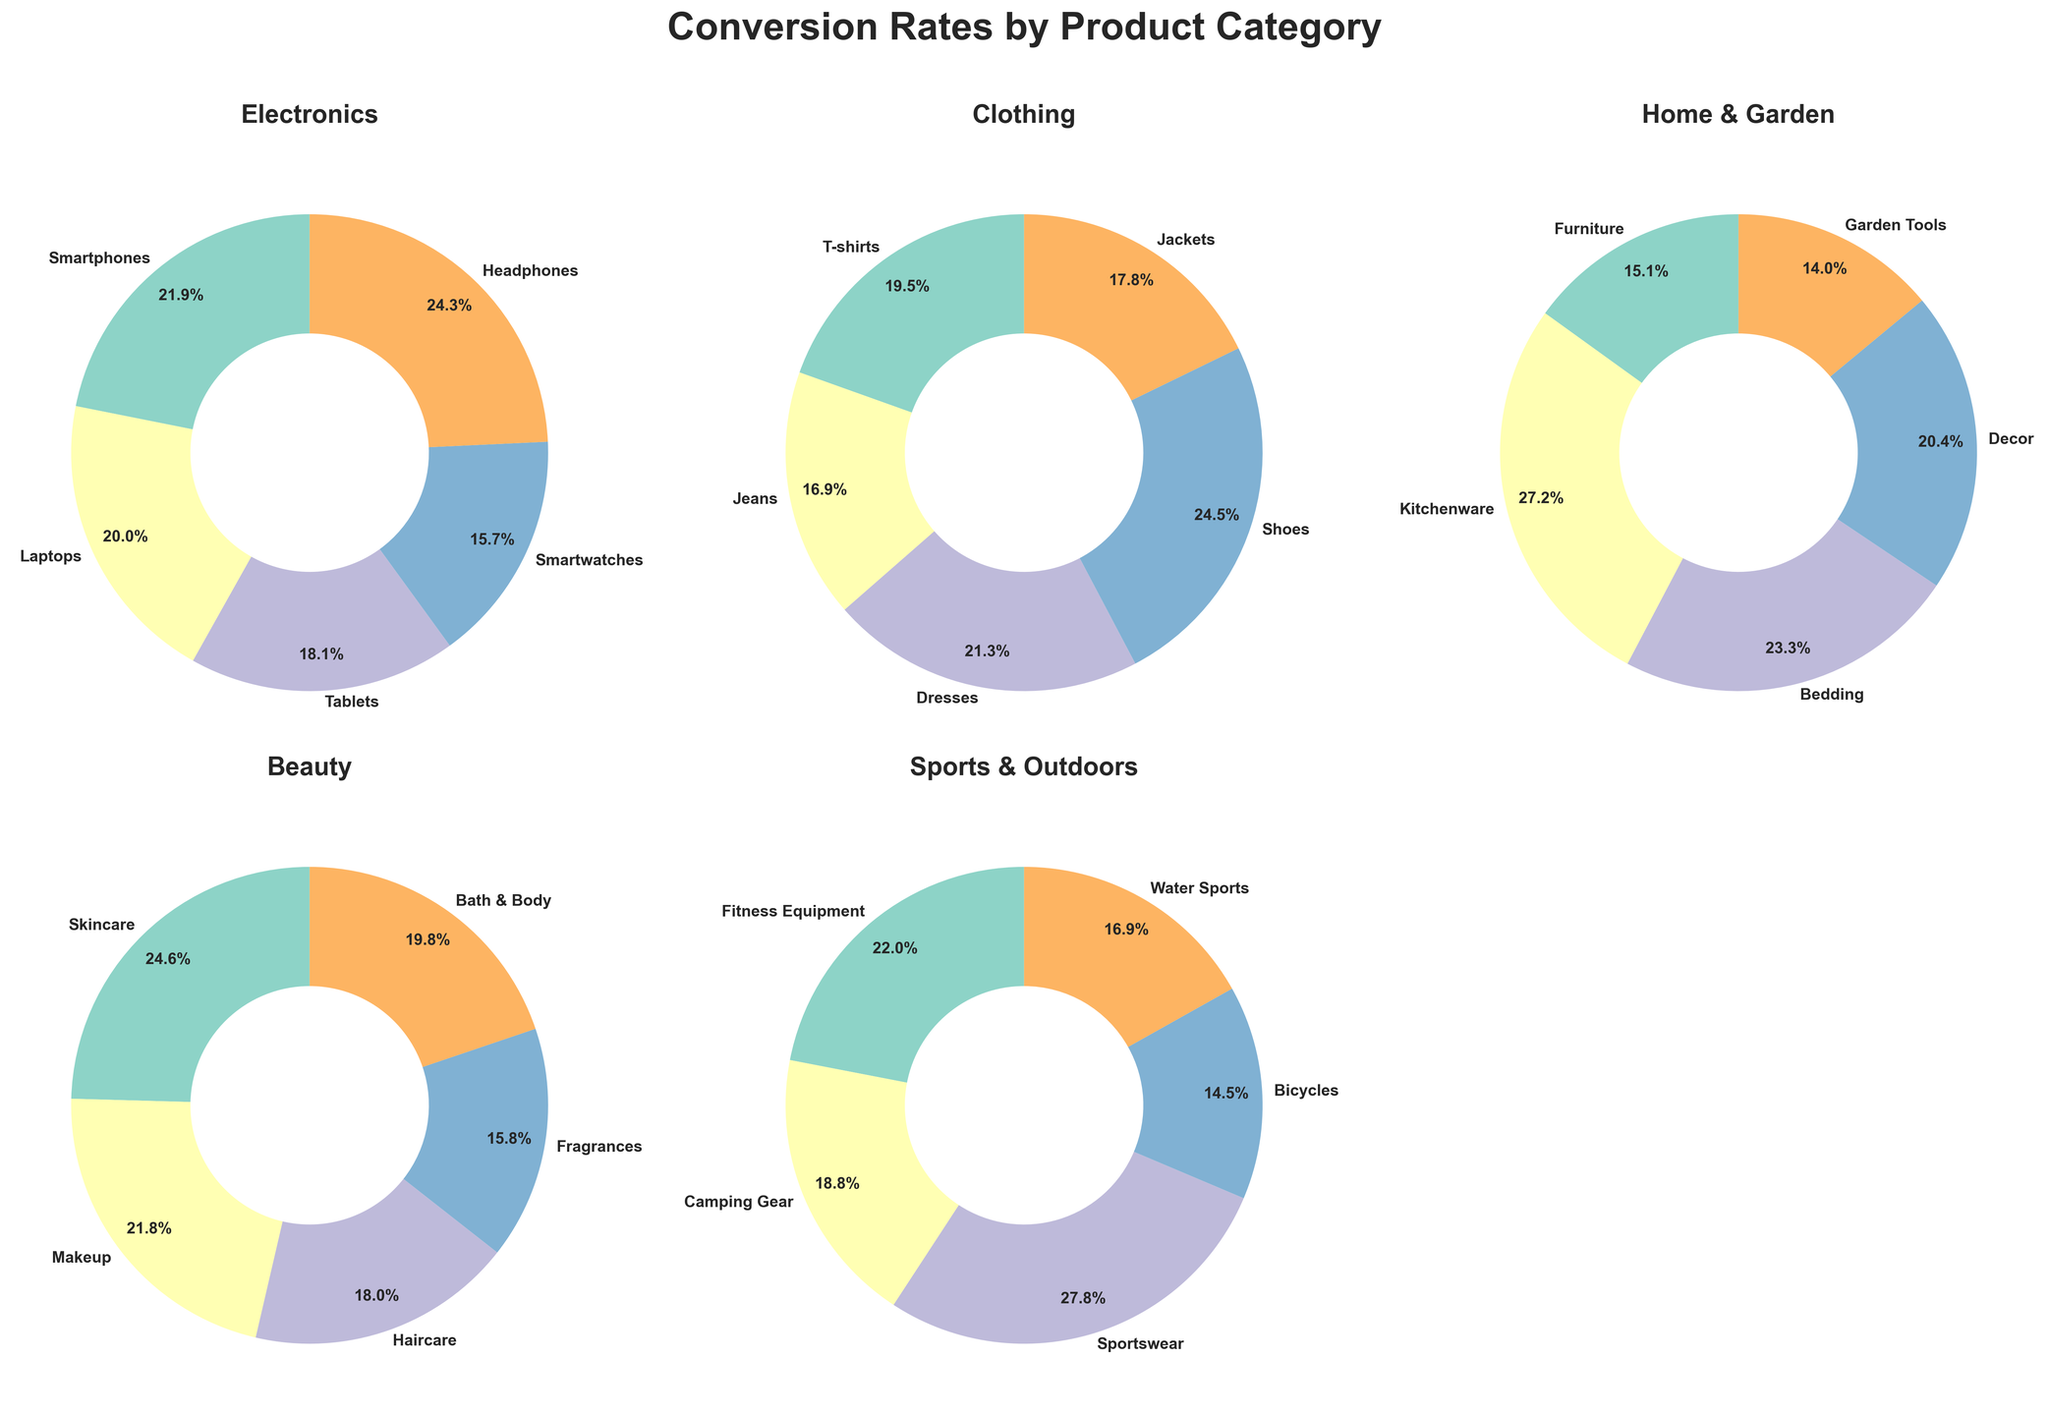Which product in the Electronics category has the highest conversion rate? In the Electronics category pie chart, Headphones have the largest section, indicating the highest conversion rate.
Answer: Headphones What is the total conversion rate for the products in the Beauty category? Sum the conversion rates for all products in the Beauty category from the pie chart: 9.8% (Skincare) + 8.7% (Makeup) + 7.2% (Haircare) + 6.3% (Fragrances) + 7.9% (Bath & Body) = 39.9%.
Answer: 39.9% Compare the conversion rate for T-shirts and Shoes in the Clothing category. Which is higher? In the Clothing category pie chart, Shoes have a larger section compared to T-shirts, indicating Shoes have a higher conversion rate.
Answer: Shoes What is the difference in conversion rates between Smartwatches and Tablets in the Electronics category? Subtract the conversion rate of Tablets (6.8%) from Smartwatches (5.9%): 5.9% - 6.8% = -0.9%.
Answer: -0.9% Which product in the Sports & Outdoors category has the lowest conversion rate? In the Sports & Outdoors category pie chart, Bicycles have the smallest section, indicating the lowest conversion rate.
Answer: Bicycles How does the conversion rate for Makeup (Beauty category) compare with that for Jeans (Clothing category)? Comparison between Makeup (8.7%) and Jeans (5.8%) shows that Makeup has a higher conversion rate.
Answer: Makeup Which category contains a product with a conversion rate above 9%? The Electronics category (Headphones: 9.1%) and Beauty category (Skincare: 9.8%) have products with conversion rates above 9%.
Answer: Electronics, Beauty What is the average conversion rate for products in the Home & Garden category? Average conversion rate is calculated by adding all conversion rates for Home & Garden category and dividing by the number of products: (4.2% + 7.6% + 6.5% + 5.7% + 3.9%) / 5 = 5.58%.
Answer: 5.58% Find the product with the second highest conversion rate in the Beauty category and state its value. In the Beauty category pie chart, the Skincare section is the largest (9.8%), followed by Bath & Body (7.9%), making it the second highest conversion rate.
Answer: Bath & Body (7.9%) Which category has the most evenly distributed conversion rates among its products? By visually comparing pie charts, the Electronics category has the most sections of nearly equal size, indicating more evenly distributed conversion rates.
Answer: Electronics 